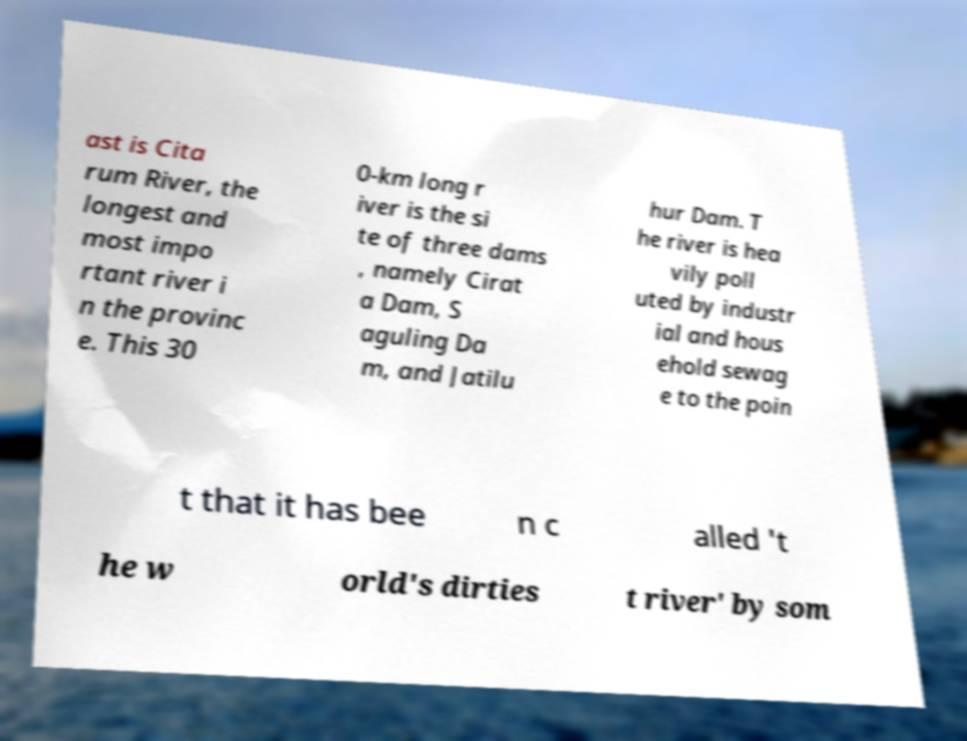There's text embedded in this image that I need extracted. Can you transcribe it verbatim? ast is Cita rum River, the longest and most impo rtant river i n the provinc e. This 30 0-km long r iver is the si te of three dams , namely Cirat a Dam, S aguling Da m, and Jatilu hur Dam. T he river is hea vily poll uted by industr ial and hous ehold sewag e to the poin t that it has bee n c alled 't he w orld's dirties t river' by som 